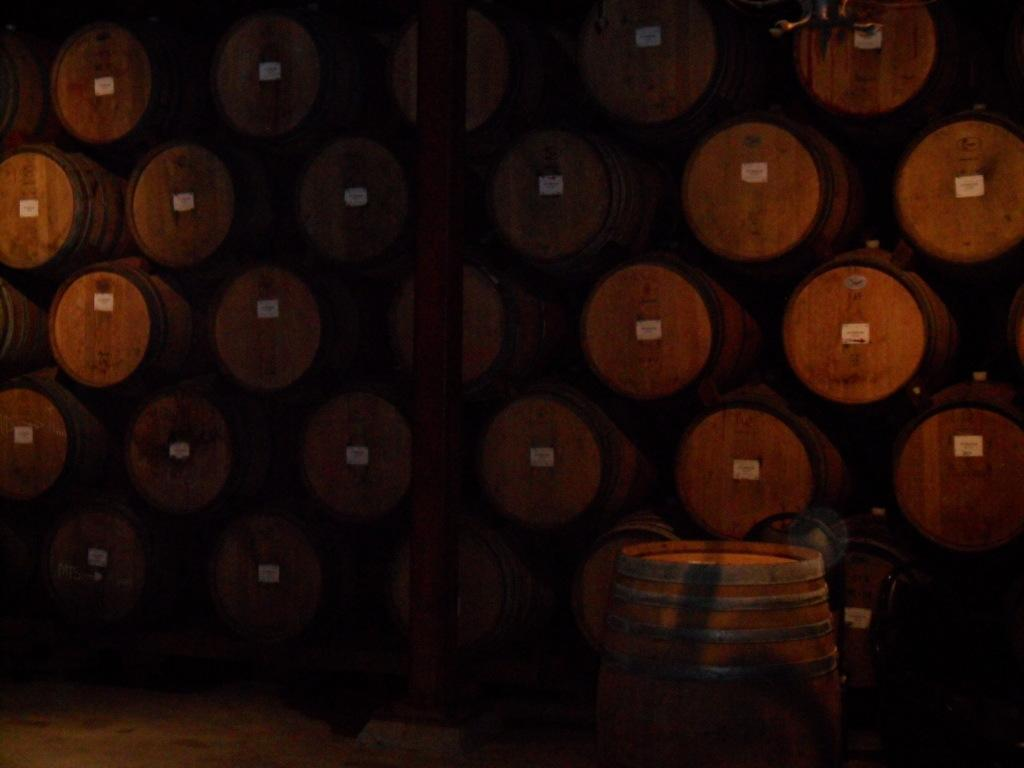What is the main object in the foreground of the image? There is a barrel in the foreground of the image. What can be seen in the background of the image? There are pyramids of barrels and a pole in the background of the image. What type of board is being used by the dad in the image? There is no dad or board present in the image. 